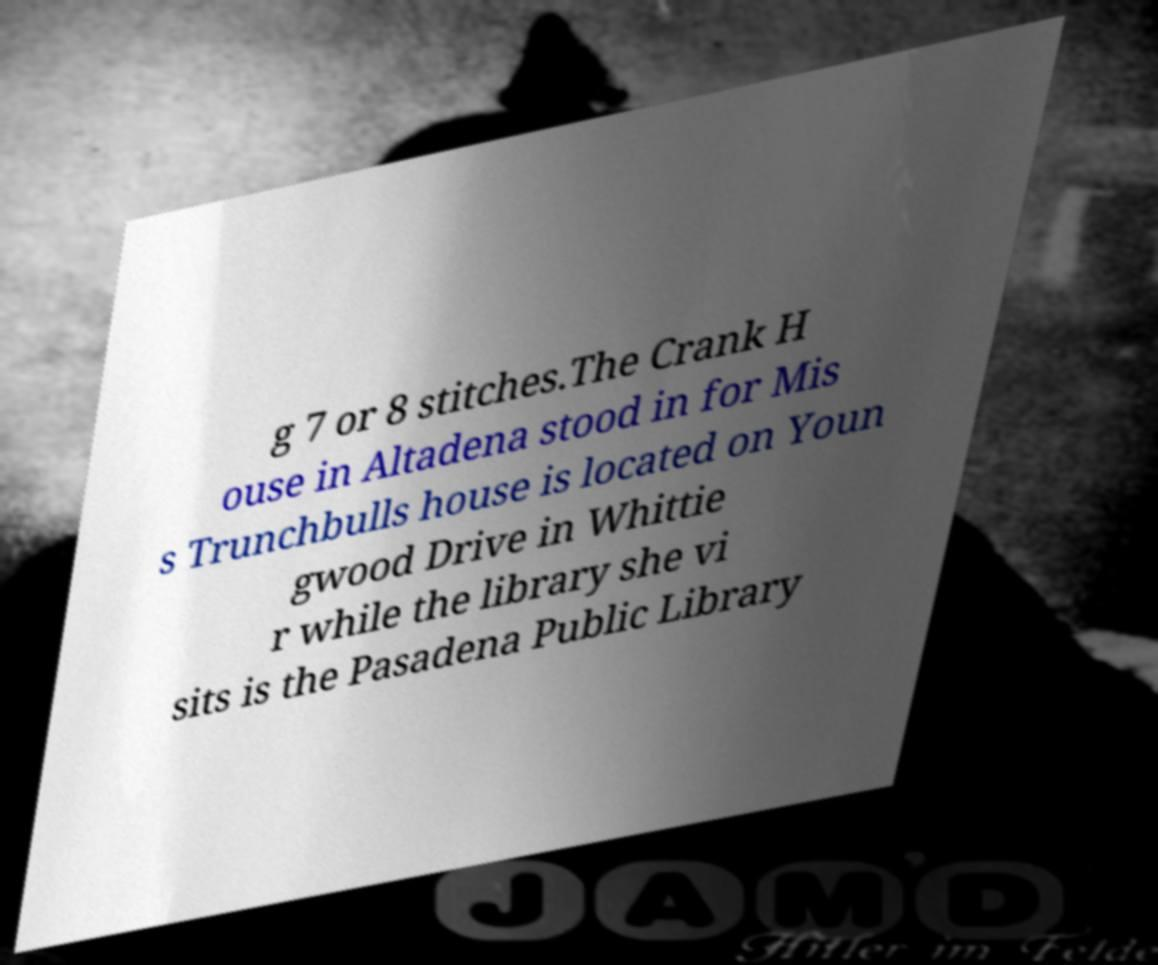For documentation purposes, I need the text within this image transcribed. Could you provide that? g 7 or 8 stitches.The Crank H ouse in Altadena stood in for Mis s Trunchbulls house is located on Youn gwood Drive in Whittie r while the library she vi sits is the Pasadena Public Library 